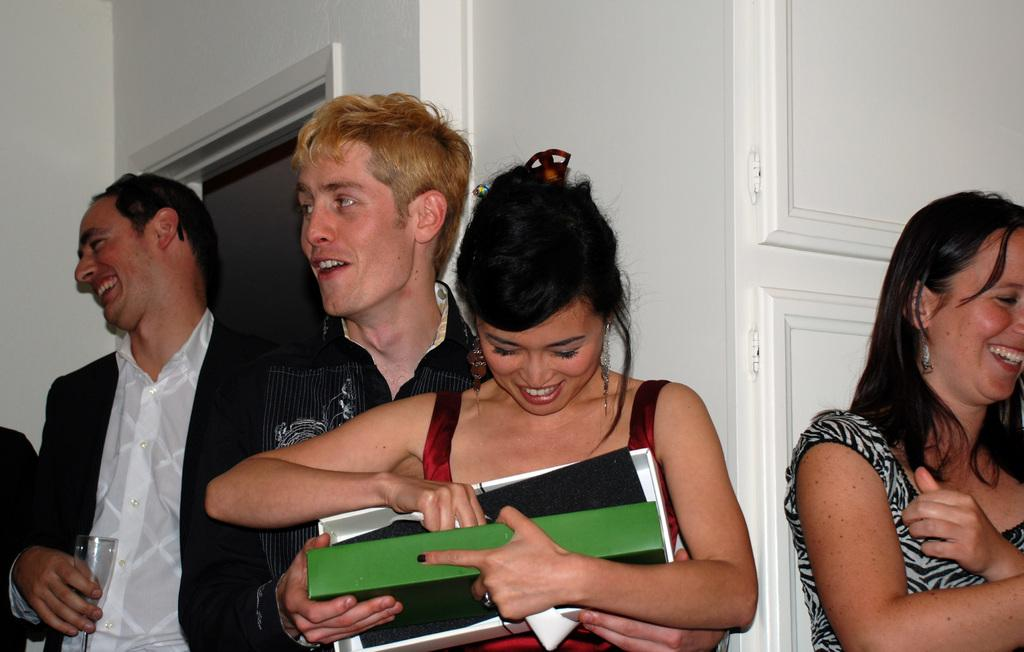Who is present in the image? There are people in the image. What expression do the people have? The people are smiling. What can be seen in the background of the image? There is a wall and a door in the background of the image. How many ladybugs can be seen on the wall in the image? There are no ladybugs present in the image; only people, a wall, and a door can be seen. 